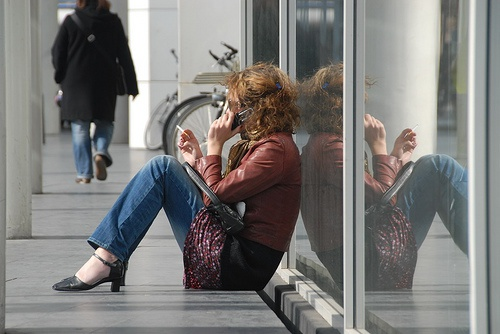Describe the objects in this image and their specific colors. I can see people in gray, black, maroon, brown, and navy tones, people in gray, black, and darkgray tones, bicycle in gray, darkgray, and black tones, handbag in gray, black, and darkgray tones, and bicycle in gray, darkgray, and lightgray tones in this image. 